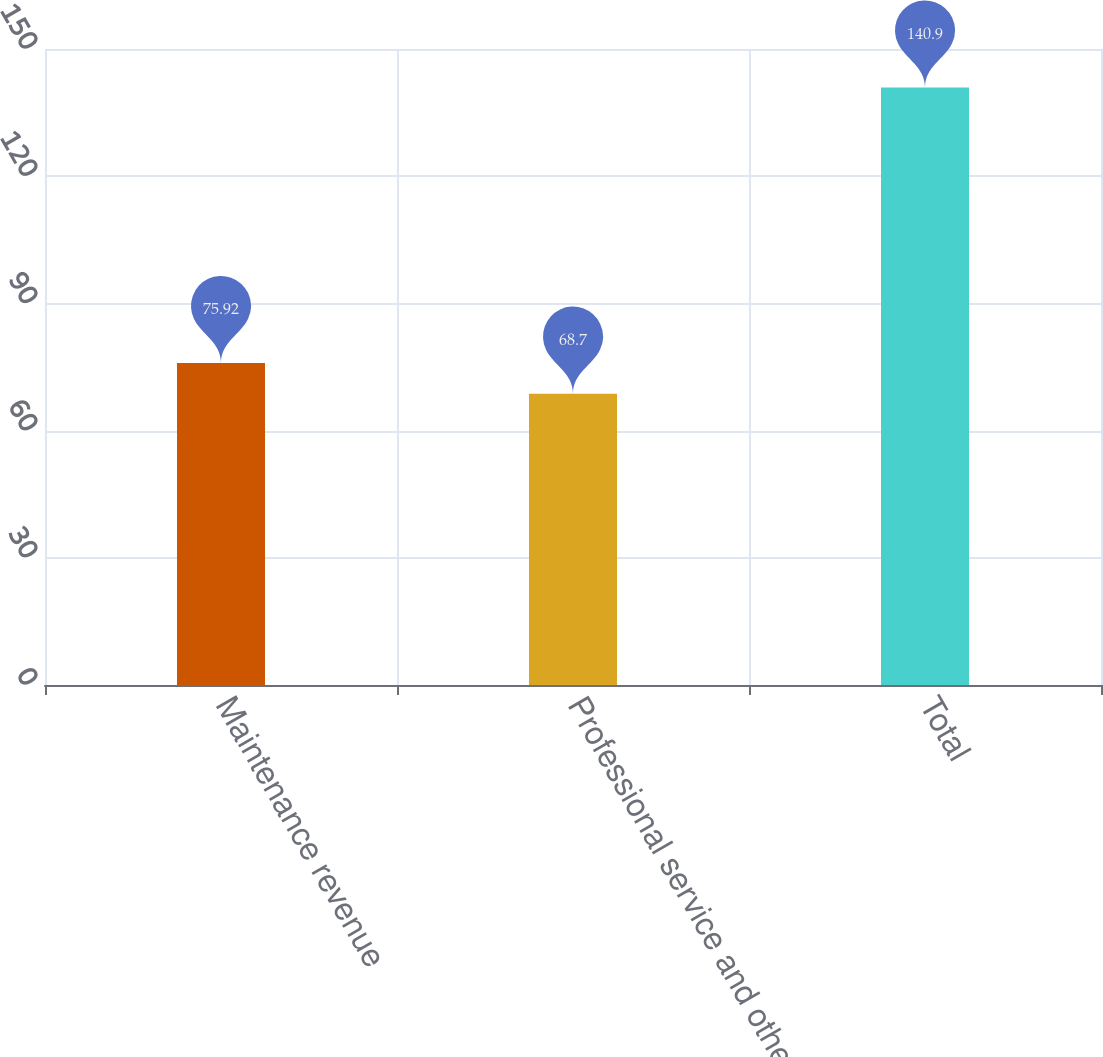<chart> <loc_0><loc_0><loc_500><loc_500><bar_chart><fcel>Maintenance revenue<fcel>Professional service and other<fcel>Total<nl><fcel>75.92<fcel>68.7<fcel>140.9<nl></chart> 